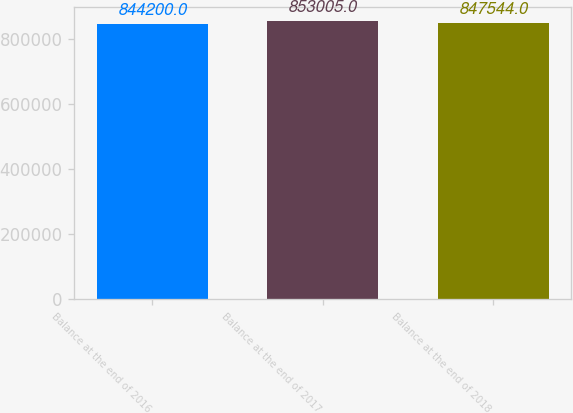<chart> <loc_0><loc_0><loc_500><loc_500><bar_chart><fcel>Balance at the end of 2016<fcel>Balance at the end of 2017<fcel>Balance at the end of 2018<nl><fcel>844200<fcel>853005<fcel>847544<nl></chart> 